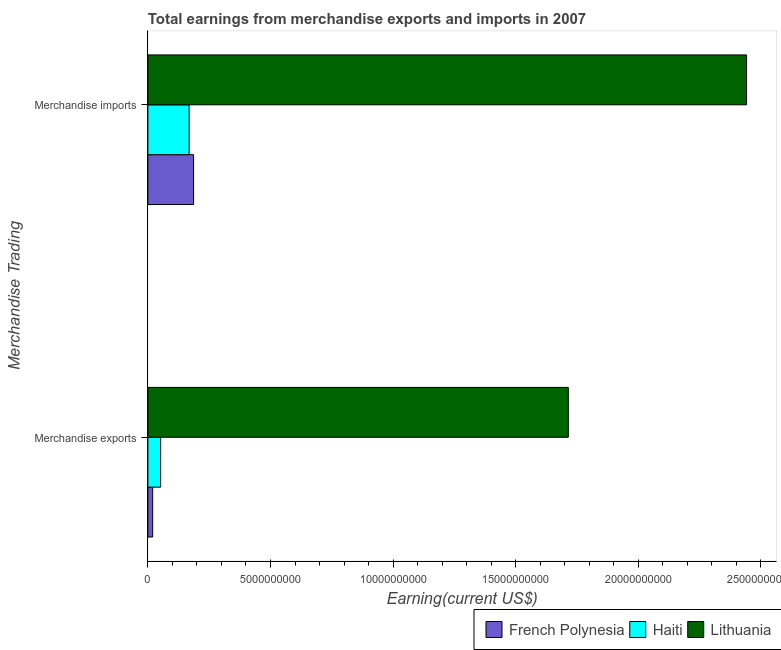How many different coloured bars are there?
Provide a short and direct response. 3. Are the number of bars per tick equal to the number of legend labels?
Offer a very short reply. Yes. Are the number of bars on each tick of the Y-axis equal?
Offer a very short reply. Yes. What is the earnings from merchandise imports in Haiti?
Offer a terse response. 1.68e+09. Across all countries, what is the maximum earnings from merchandise imports?
Your answer should be very brief. 2.44e+1. Across all countries, what is the minimum earnings from merchandise imports?
Make the answer very short. 1.68e+09. In which country was the earnings from merchandise imports maximum?
Your answer should be very brief. Lithuania. In which country was the earnings from merchandise exports minimum?
Give a very brief answer. French Polynesia. What is the total earnings from merchandise exports in the graph?
Give a very brief answer. 1.79e+1. What is the difference between the earnings from merchandise imports in French Polynesia and that in Haiti?
Give a very brief answer. 1.82e+08. What is the difference between the earnings from merchandise imports in Lithuania and the earnings from merchandise exports in French Polynesia?
Ensure brevity in your answer.  2.42e+1. What is the average earnings from merchandise imports per country?
Offer a very short reply. 9.32e+09. What is the difference between the earnings from merchandise imports and earnings from merchandise exports in French Polynesia?
Your answer should be very brief. 1.67e+09. What is the ratio of the earnings from merchandise imports in Haiti to that in Lithuania?
Your answer should be compact. 0.07. Is the earnings from merchandise exports in Haiti less than that in French Polynesia?
Provide a succinct answer. No. What does the 3rd bar from the top in Merchandise exports represents?
Your answer should be very brief. French Polynesia. What does the 1st bar from the bottom in Merchandise exports represents?
Your response must be concise. French Polynesia. How many bars are there?
Offer a terse response. 6. Are all the bars in the graph horizontal?
Keep it short and to the point. Yes. Does the graph contain grids?
Keep it short and to the point. No. Where does the legend appear in the graph?
Your answer should be very brief. Bottom right. How are the legend labels stacked?
Ensure brevity in your answer.  Horizontal. What is the title of the graph?
Your answer should be very brief. Total earnings from merchandise exports and imports in 2007. What is the label or title of the X-axis?
Your response must be concise. Earning(current US$). What is the label or title of the Y-axis?
Provide a succinct answer. Merchandise Trading. What is the Earning(current US$) in French Polynesia in Merchandise exports?
Your answer should be very brief. 1.97e+08. What is the Earning(current US$) in Haiti in Merchandise exports?
Your response must be concise. 5.22e+08. What is the Earning(current US$) in Lithuania in Merchandise exports?
Your response must be concise. 1.71e+1. What is the Earning(current US$) in French Polynesia in Merchandise imports?
Provide a succinct answer. 1.86e+09. What is the Earning(current US$) in Haiti in Merchandise imports?
Provide a succinct answer. 1.68e+09. What is the Earning(current US$) of Lithuania in Merchandise imports?
Offer a very short reply. 2.44e+1. Across all Merchandise Trading, what is the maximum Earning(current US$) of French Polynesia?
Provide a short and direct response. 1.86e+09. Across all Merchandise Trading, what is the maximum Earning(current US$) in Haiti?
Your answer should be compact. 1.68e+09. Across all Merchandise Trading, what is the maximum Earning(current US$) in Lithuania?
Offer a very short reply. 2.44e+1. Across all Merchandise Trading, what is the minimum Earning(current US$) of French Polynesia?
Offer a terse response. 1.97e+08. Across all Merchandise Trading, what is the minimum Earning(current US$) in Haiti?
Make the answer very short. 5.22e+08. Across all Merchandise Trading, what is the minimum Earning(current US$) of Lithuania?
Ensure brevity in your answer.  1.71e+1. What is the total Earning(current US$) of French Polynesia in the graph?
Keep it short and to the point. 2.06e+09. What is the total Earning(current US$) in Haiti in the graph?
Keep it short and to the point. 2.20e+09. What is the total Earning(current US$) of Lithuania in the graph?
Provide a succinct answer. 4.16e+1. What is the difference between the Earning(current US$) of French Polynesia in Merchandise exports and that in Merchandise imports?
Make the answer very short. -1.67e+09. What is the difference between the Earning(current US$) in Haiti in Merchandise exports and that in Merchandise imports?
Offer a very short reply. -1.16e+09. What is the difference between the Earning(current US$) in Lithuania in Merchandise exports and that in Merchandise imports?
Provide a succinct answer. -7.27e+09. What is the difference between the Earning(current US$) in French Polynesia in Merchandise exports and the Earning(current US$) in Haiti in Merchandise imports?
Your answer should be compact. -1.48e+09. What is the difference between the Earning(current US$) in French Polynesia in Merchandise exports and the Earning(current US$) in Lithuania in Merchandise imports?
Offer a very short reply. -2.42e+1. What is the difference between the Earning(current US$) of Haiti in Merchandise exports and the Earning(current US$) of Lithuania in Merchandise imports?
Make the answer very short. -2.39e+1. What is the average Earning(current US$) of French Polynesia per Merchandise Trading?
Offer a very short reply. 1.03e+09. What is the average Earning(current US$) in Haiti per Merchandise Trading?
Ensure brevity in your answer.  1.10e+09. What is the average Earning(current US$) of Lithuania per Merchandise Trading?
Your answer should be very brief. 2.08e+1. What is the difference between the Earning(current US$) in French Polynesia and Earning(current US$) in Haiti in Merchandise exports?
Offer a terse response. -3.25e+08. What is the difference between the Earning(current US$) in French Polynesia and Earning(current US$) in Lithuania in Merchandise exports?
Ensure brevity in your answer.  -1.69e+1. What is the difference between the Earning(current US$) of Haiti and Earning(current US$) of Lithuania in Merchandise exports?
Ensure brevity in your answer.  -1.66e+1. What is the difference between the Earning(current US$) in French Polynesia and Earning(current US$) in Haiti in Merchandise imports?
Your response must be concise. 1.82e+08. What is the difference between the Earning(current US$) in French Polynesia and Earning(current US$) in Lithuania in Merchandise imports?
Ensure brevity in your answer.  -2.25e+1. What is the difference between the Earning(current US$) in Haiti and Earning(current US$) in Lithuania in Merchandise imports?
Your response must be concise. -2.27e+1. What is the ratio of the Earning(current US$) of French Polynesia in Merchandise exports to that in Merchandise imports?
Make the answer very short. 0.11. What is the ratio of the Earning(current US$) of Haiti in Merchandise exports to that in Merchandise imports?
Your response must be concise. 0.31. What is the ratio of the Earning(current US$) in Lithuania in Merchandise exports to that in Merchandise imports?
Ensure brevity in your answer.  0.7. What is the difference between the highest and the second highest Earning(current US$) of French Polynesia?
Provide a short and direct response. 1.67e+09. What is the difference between the highest and the second highest Earning(current US$) of Haiti?
Your answer should be compact. 1.16e+09. What is the difference between the highest and the second highest Earning(current US$) of Lithuania?
Your answer should be very brief. 7.27e+09. What is the difference between the highest and the lowest Earning(current US$) in French Polynesia?
Keep it short and to the point. 1.67e+09. What is the difference between the highest and the lowest Earning(current US$) of Haiti?
Keep it short and to the point. 1.16e+09. What is the difference between the highest and the lowest Earning(current US$) of Lithuania?
Keep it short and to the point. 7.27e+09. 